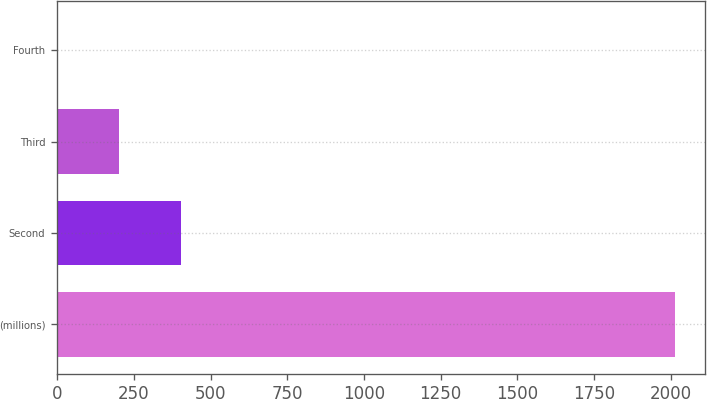Convert chart to OTSL. <chart><loc_0><loc_0><loc_500><loc_500><bar_chart><fcel>(millions)<fcel>Second<fcel>Third<fcel>Fourth<nl><fcel>2012<fcel>402.47<fcel>201.28<fcel>0.09<nl></chart> 